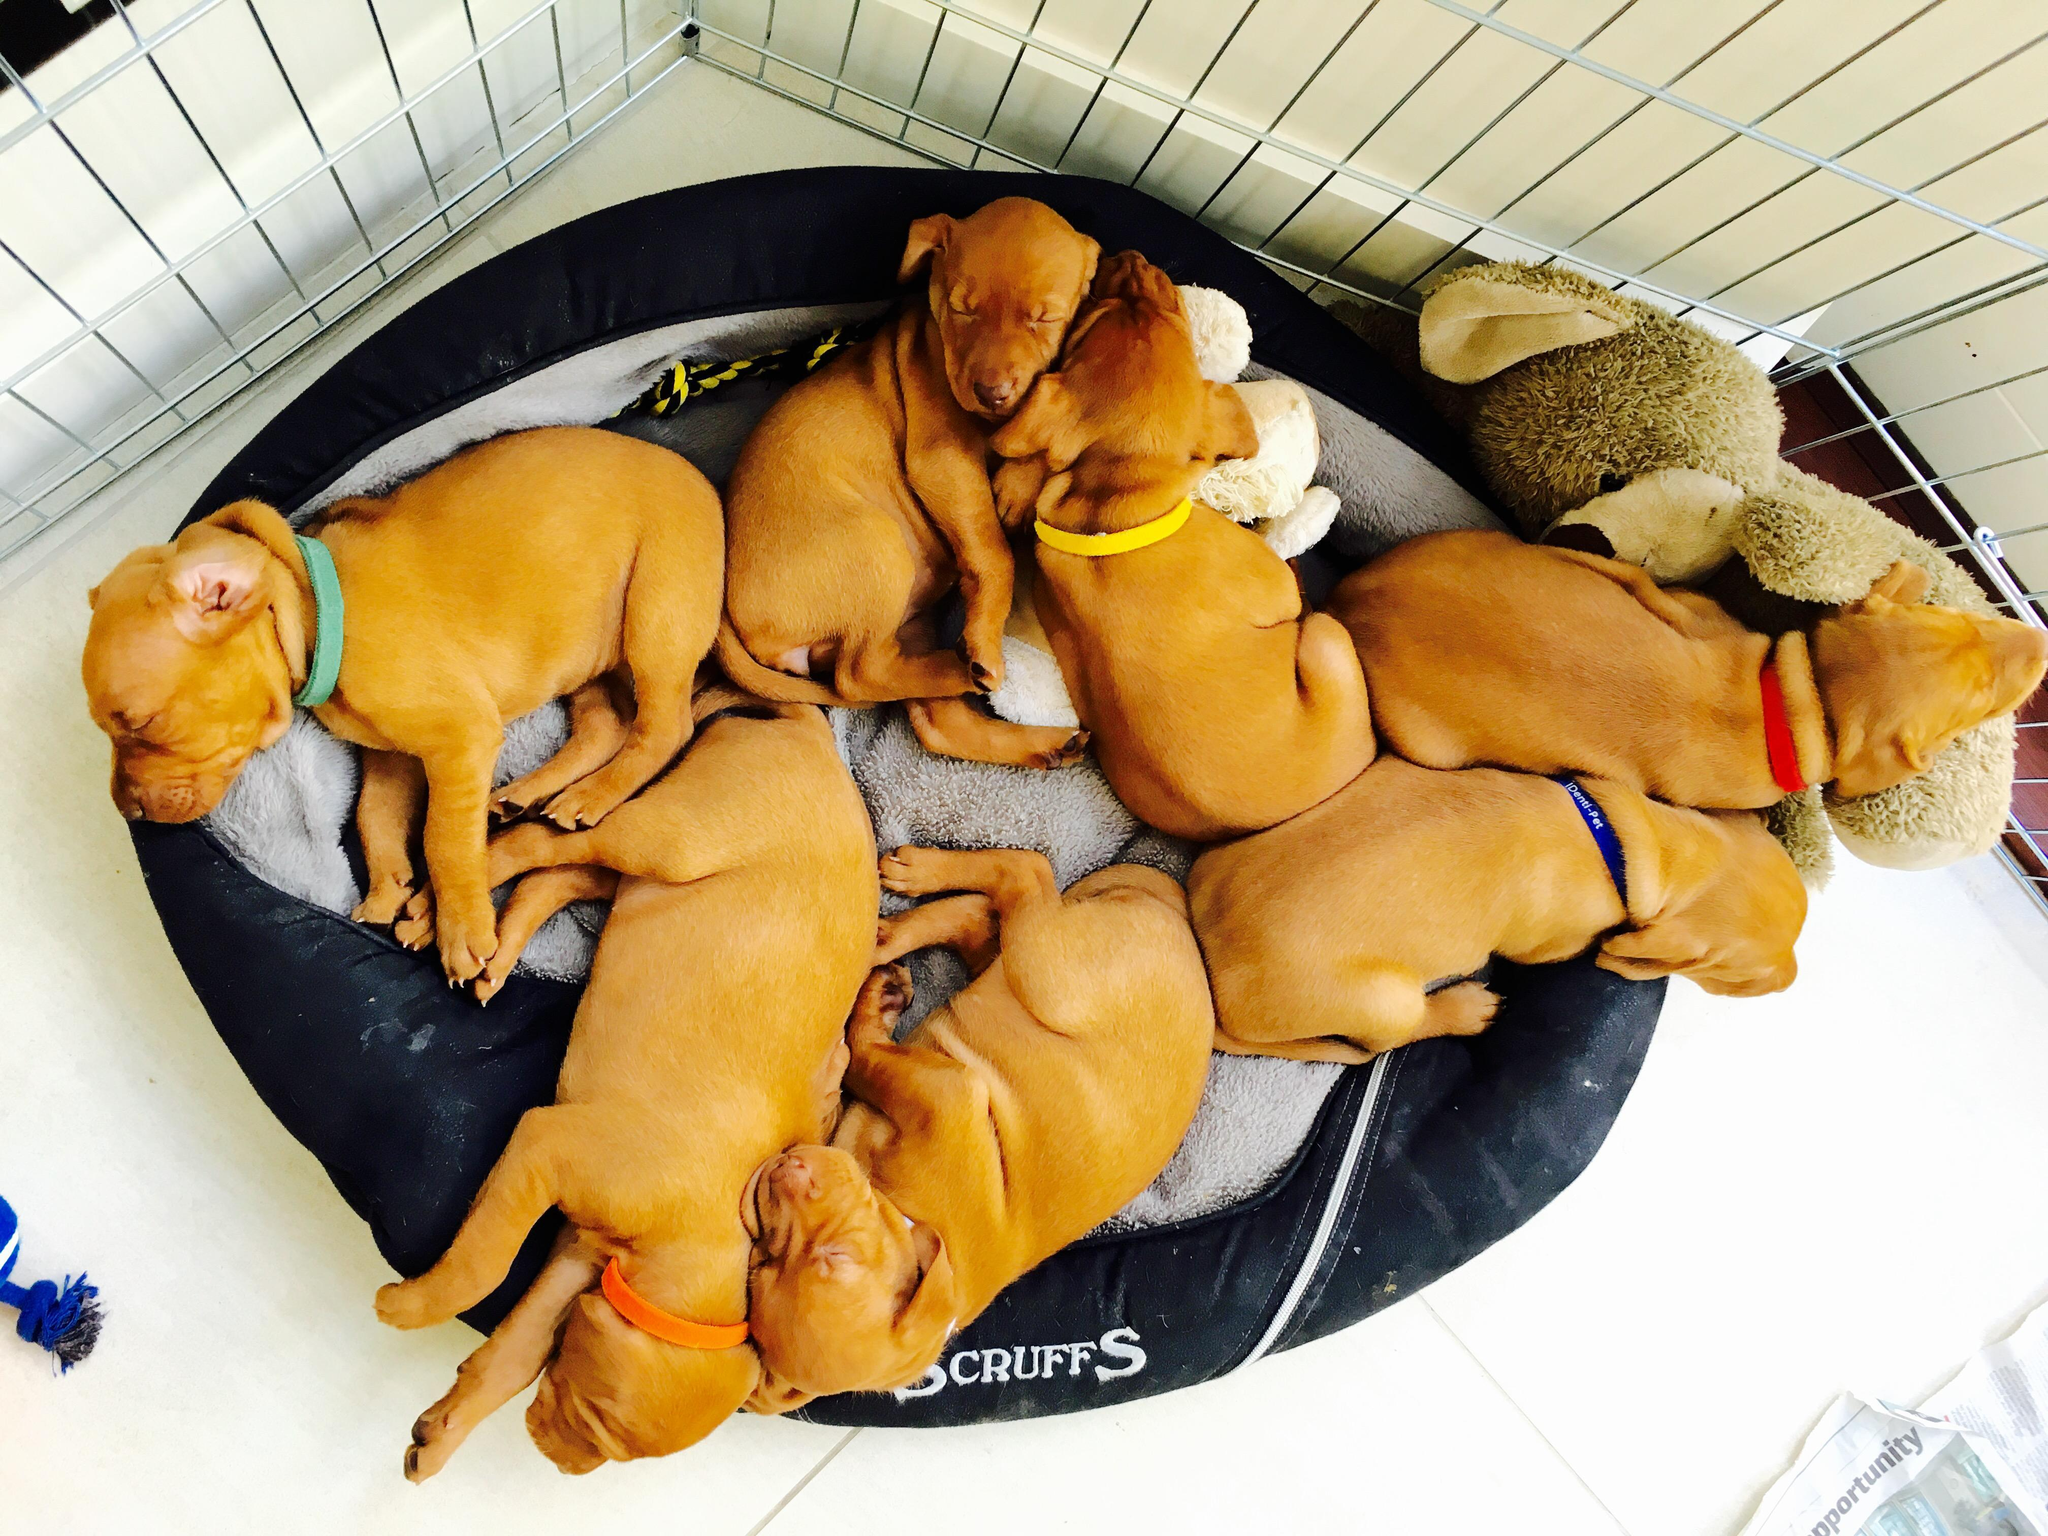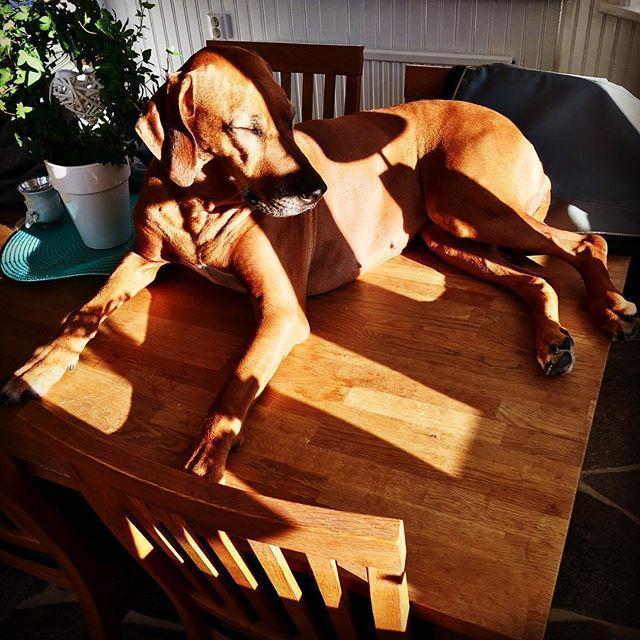The first image is the image on the left, the second image is the image on the right. For the images displayed, is the sentence "One image shows a container holding seven red-orange puppies, and the other image shows one sleeping adult dog." factually correct? Answer yes or no. Yes. The first image is the image on the left, the second image is the image on the right. Considering the images on both sides, is "There are more than three puppies sleeping in the image." valid? Answer yes or no. Yes. 